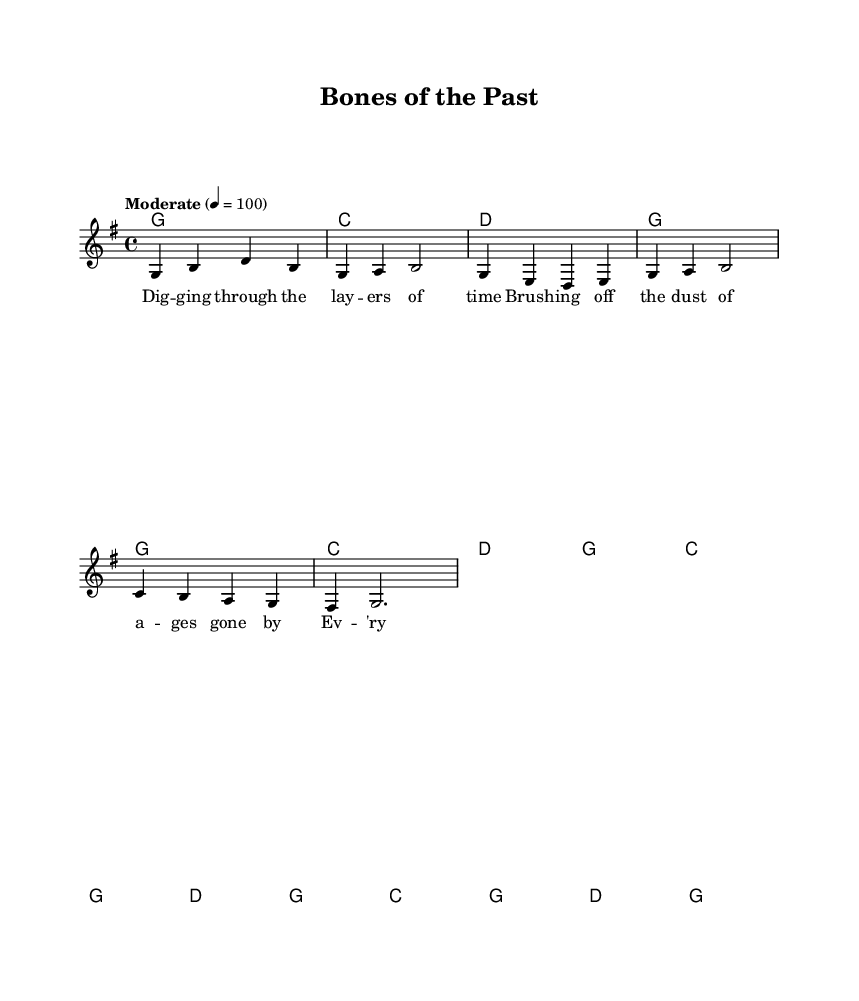what is the key signature of this music? The key signature is G major, which has one sharp (F#). This is indicated at the beginning of the staff where the key signature is shown.
Answer: G major what is the time signature of this music? The time signature is 4/4, as indicated at the beginning of the score right after the key signature. This means there are four beats in each measure and the quarter note receives one beat.
Answer: 4/4 what is the tempo marking for this piece? The tempo marking is "Moderate" with a speed of 100 beats per minute, as indicated at the beginning of the score. This gives an idea of how fast the music should be played.
Answer: Moderate 4 = 100 how many measures are in the verse? The verse contains 8 measures, as clearly indicated by the layout of the music where each measure is separated by vertical lines and the verse is written above the chords and lyrics.
Answer: 8 measures what is the structure of the song regarding the sections shown in the sheet music? The song consists of a verse followed by a chorus, as evidenced by the arrangement where verse lyrics and chords are presented first, followed by the chorus lyrics and chords. This is common in country music for storytelling purposes.
Answer: Verse, Chorus which chord is played in the first measure of the verse? The chord played in the first measure of the verse is G major, indicated at the start of the measure in the chord names section. This sets the harmonic foundation for that phrase of the melody.
Answer: G what is the emotional theme expressed in the chorus lyrics? The emotional theme expressed in the chorus lyrics is excitement and passion about discovering the past, emphasized by phrases like "each discovery makes my heart beat fast." This suggests a sense of wonder often found in country music.
Answer: Excitement 